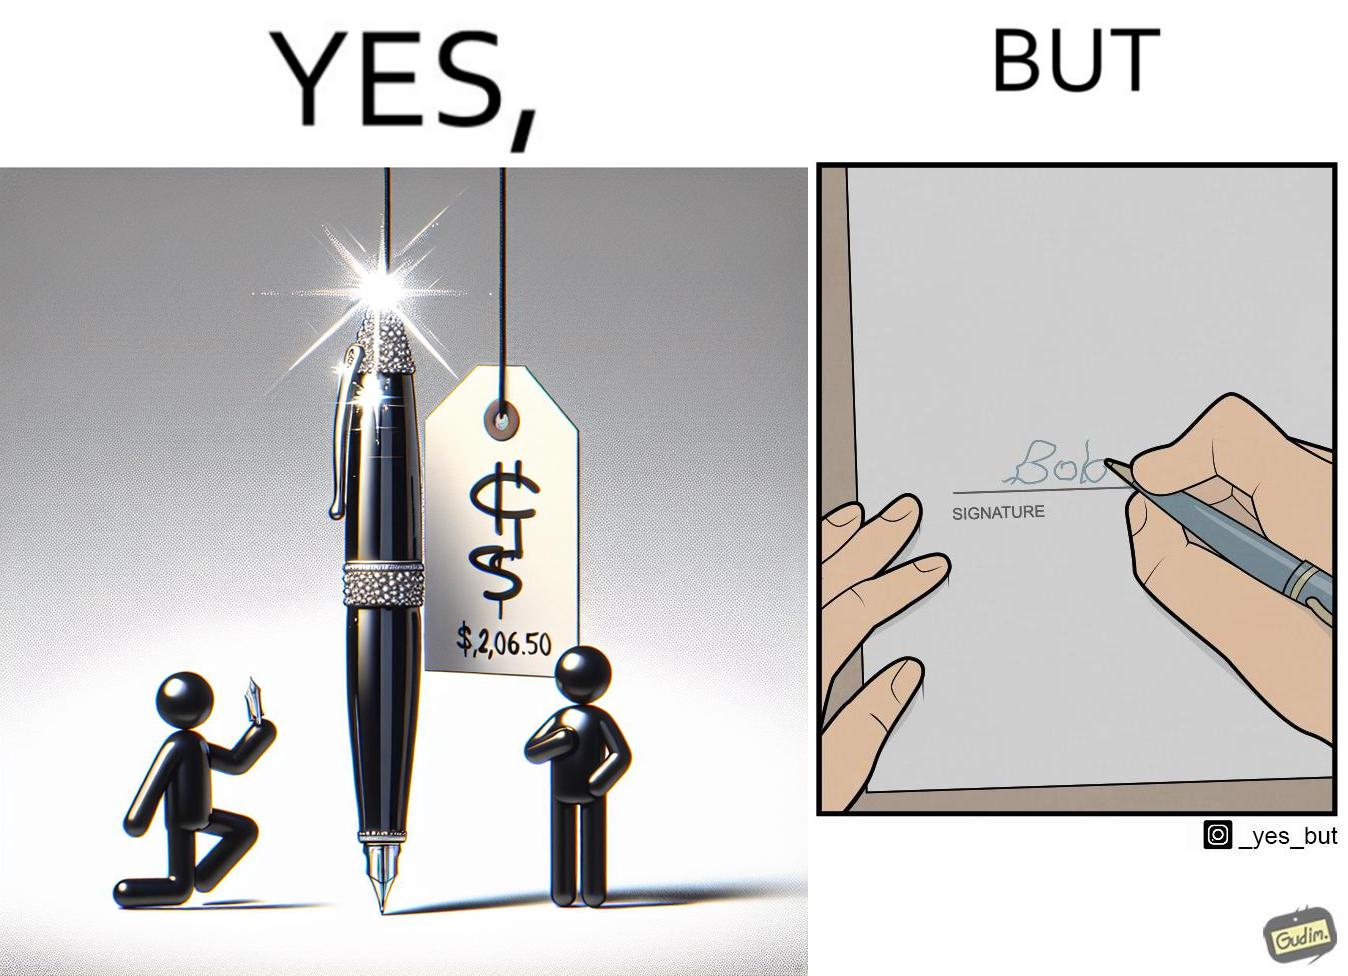Explain why this image is satirical. The image is ironic, because it conveys the message that even with the costliest of pens people handwriting remains the same 